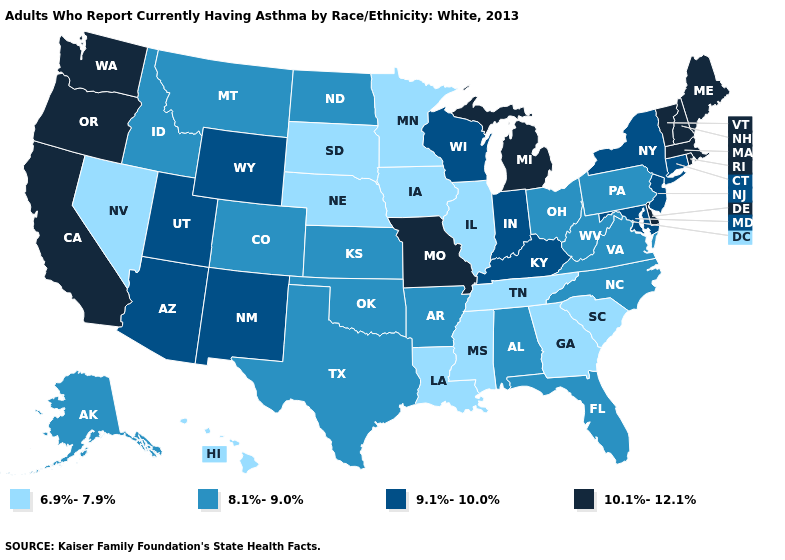What is the value of California?
Give a very brief answer. 10.1%-12.1%. What is the lowest value in the South?
Quick response, please. 6.9%-7.9%. Is the legend a continuous bar?
Concise answer only. No. Among the states that border Maine , which have the lowest value?
Answer briefly. New Hampshire. Name the states that have a value in the range 6.9%-7.9%?
Short answer required. Georgia, Hawaii, Illinois, Iowa, Louisiana, Minnesota, Mississippi, Nebraska, Nevada, South Carolina, South Dakota, Tennessee. What is the lowest value in the South?
Concise answer only. 6.9%-7.9%. What is the value of Arizona?
Give a very brief answer. 9.1%-10.0%. Name the states that have a value in the range 9.1%-10.0%?
Quick response, please. Arizona, Connecticut, Indiana, Kentucky, Maryland, New Jersey, New Mexico, New York, Utah, Wisconsin, Wyoming. Name the states that have a value in the range 6.9%-7.9%?
Short answer required. Georgia, Hawaii, Illinois, Iowa, Louisiana, Minnesota, Mississippi, Nebraska, Nevada, South Carolina, South Dakota, Tennessee. Name the states that have a value in the range 6.9%-7.9%?
Answer briefly. Georgia, Hawaii, Illinois, Iowa, Louisiana, Minnesota, Mississippi, Nebraska, Nevada, South Carolina, South Dakota, Tennessee. Name the states that have a value in the range 6.9%-7.9%?
Short answer required. Georgia, Hawaii, Illinois, Iowa, Louisiana, Minnesota, Mississippi, Nebraska, Nevada, South Carolina, South Dakota, Tennessee. Is the legend a continuous bar?
Answer briefly. No. Name the states that have a value in the range 9.1%-10.0%?
Short answer required. Arizona, Connecticut, Indiana, Kentucky, Maryland, New Jersey, New Mexico, New York, Utah, Wisconsin, Wyoming. Among the states that border Indiana , does Illinois have the lowest value?
Write a very short answer. Yes. What is the value of Oklahoma?
Answer briefly. 8.1%-9.0%. 